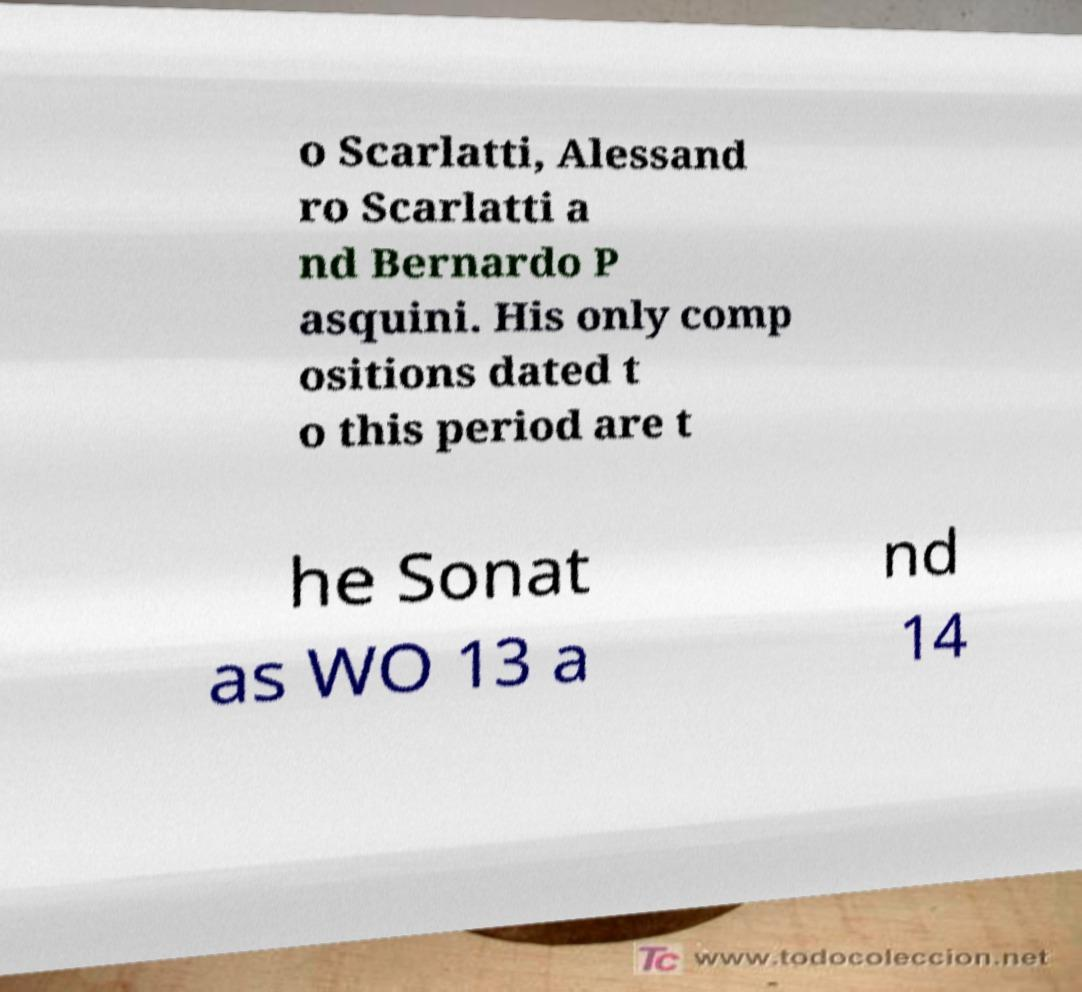I need the written content from this picture converted into text. Can you do that? o Scarlatti, Alessand ro Scarlatti a nd Bernardo P asquini. His only comp ositions dated t o this period are t he Sonat as WO 13 a nd 14 